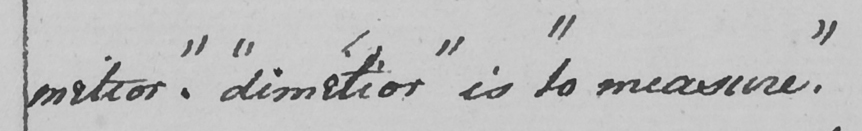Please transcribe the handwritten text in this image. mitior "  .  " dimitior "  is  " to measure "  . 